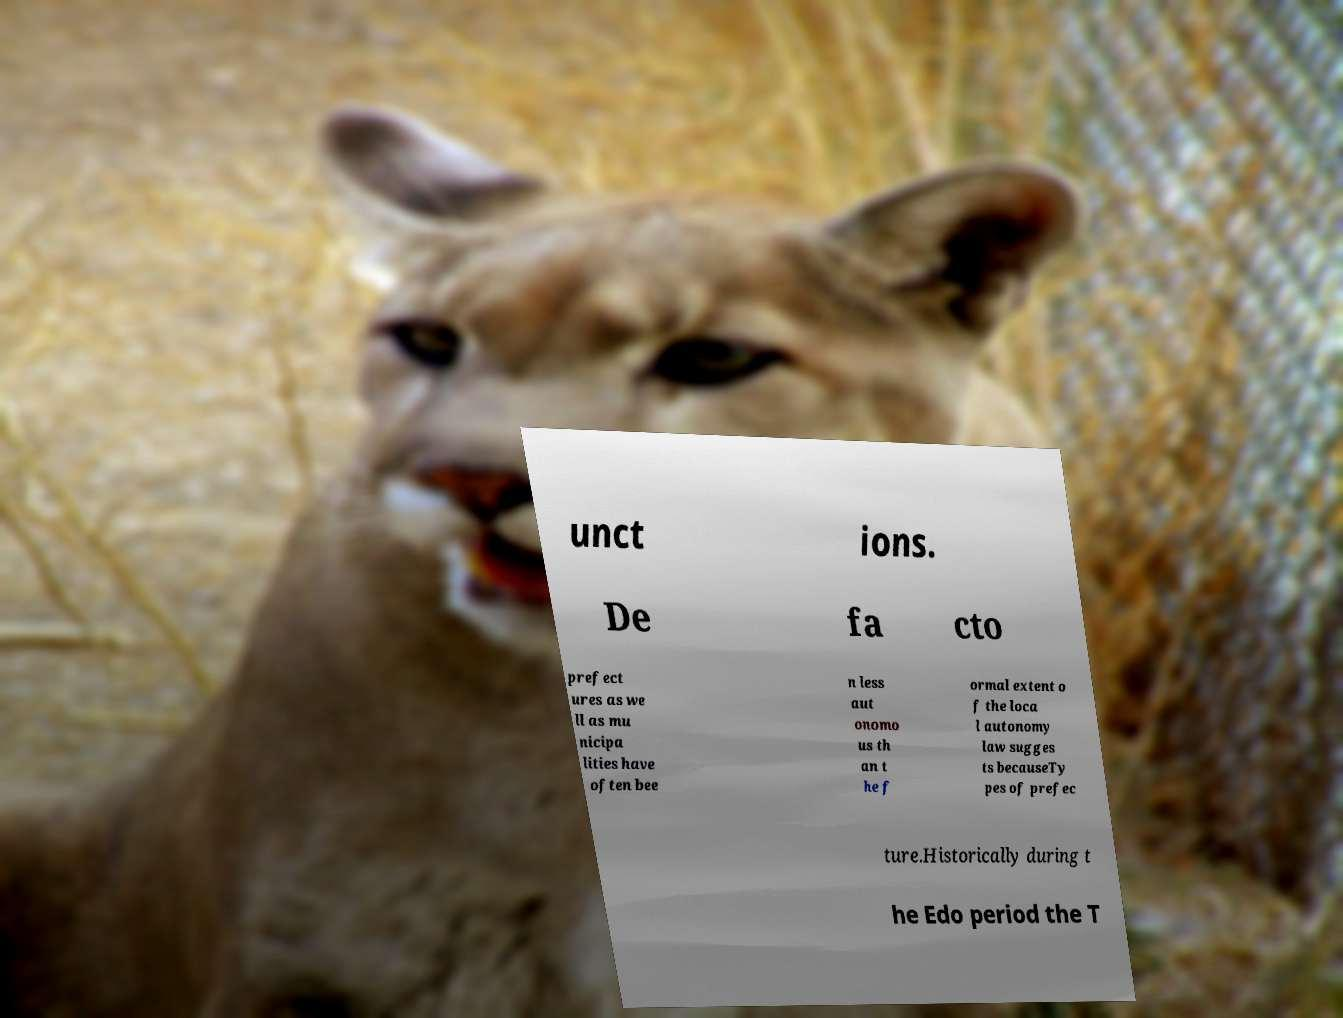Could you extract and type out the text from this image? unct ions. De fa cto prefect ures as we ll as mu nicipa lities have often bee n less aut onomo us th an t he f ormal extent o f the loca l autonomy law sugges ts becauseTy pes of prefec ture.Historically during t he Edo period the T 